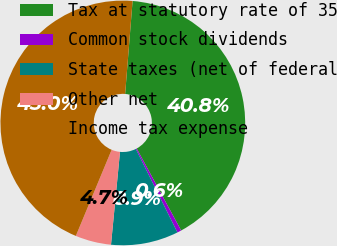Convert chart to OTSL. <chart><loc_0><loc_0><loc_500><loc_500><pie_chart><fcel>Tax at statutory rate of 35<fcel>Common stock dividends<fcel>State taxes (net of federal<fcel>Other net<fcel>Income tax expense<nl><fcel>40.82%<fcel>0.55%<fcel>8.9%<fcel>4.73%<fcel>45.0%<nl></chart> 